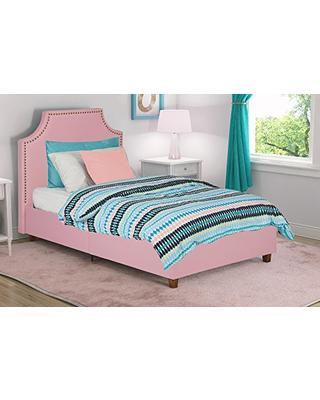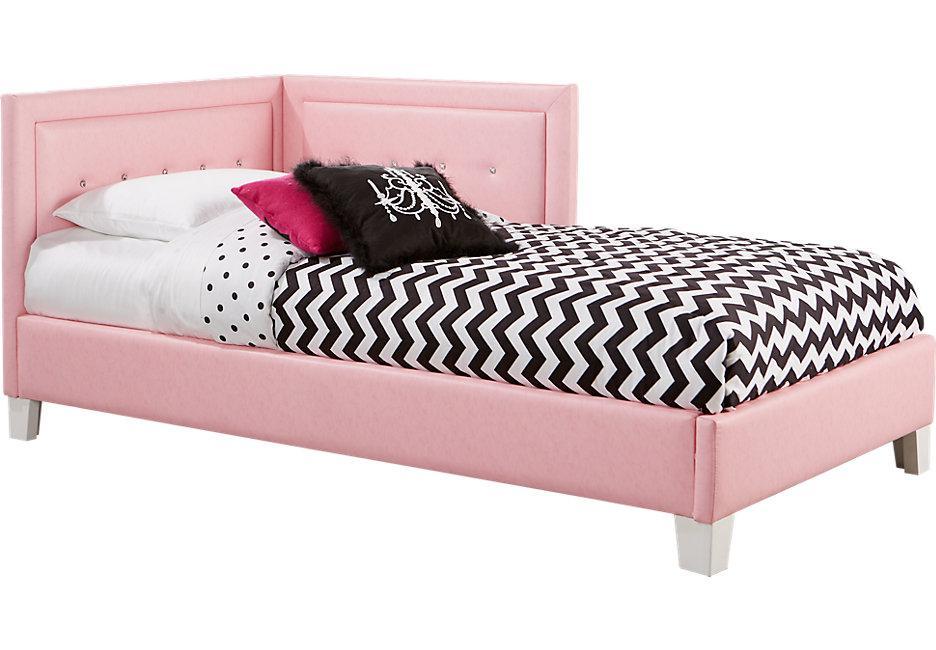The first image is the image on the left, the second image is the image on the right. For the images shown, is this caption "Both head- and foot-board of one bed are upholstered and tufted with purple fabric." true? Answer yes or no. No. The first image is the image on the left, the second image is the image on the right. Given the left and right images, does the statement "There is a single pink bed with a pull out trundle bed attached underneath it" hold true? Answer yes or no. No. 